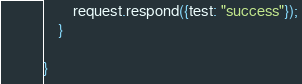<code> <loc_0><loc_0><loc_500><loc_500><_TypeScript_>        request.respond({test: "success"});
    }

}</code> 